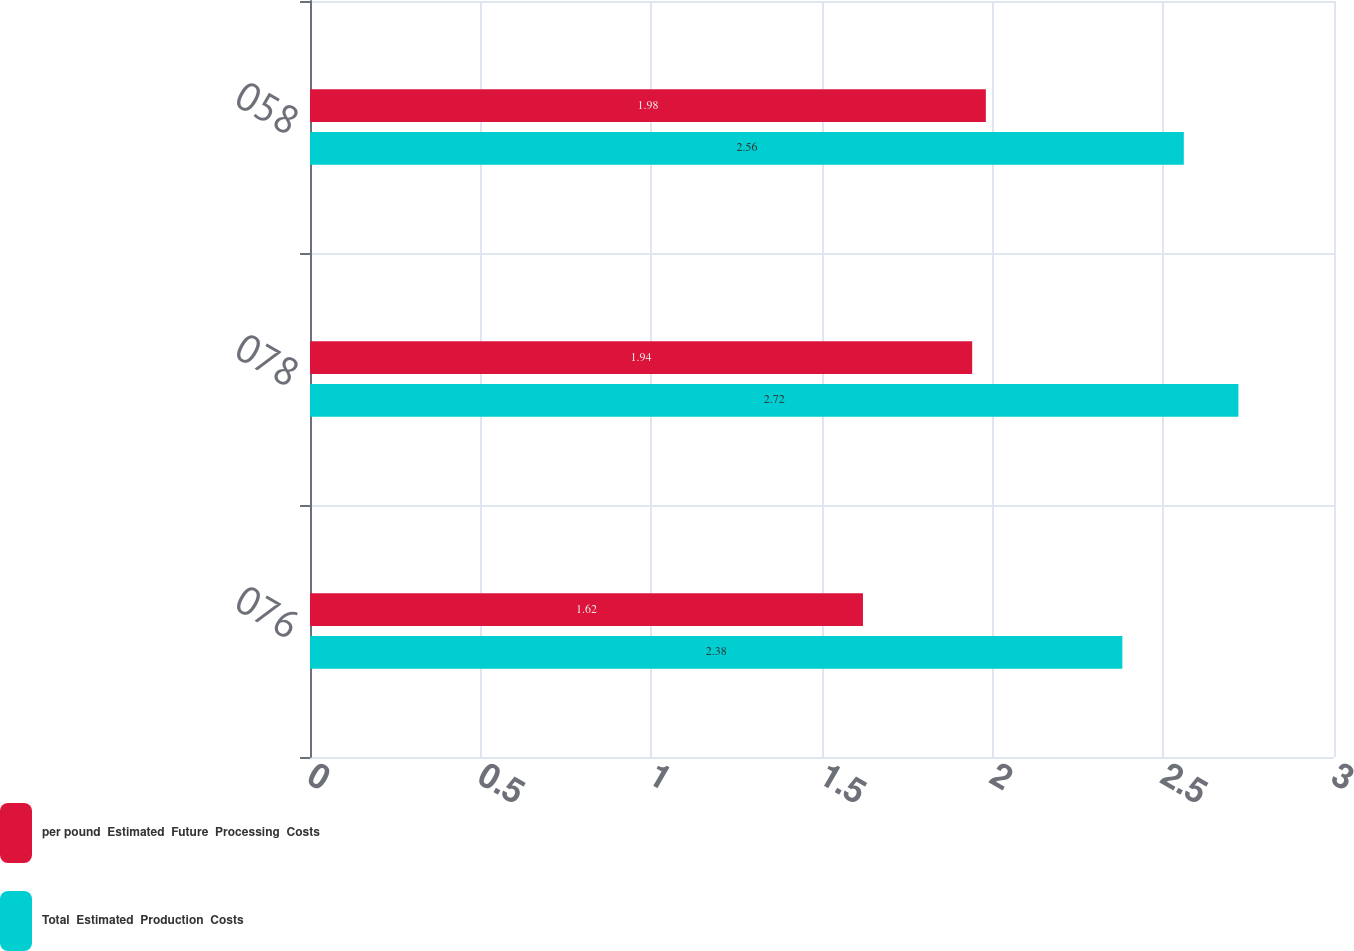<chart> <loc_0><loc_0><loc_500><loc_500><stacked_bar_chart><ecel><fcel>076<fcel>078<fcel>058<nl><fcel>per pound  Estimated  Future  Processing  Costs<fcel>1.62<fcel>1.94<fcel>1.98<nl><fcel>Total  Estimated  Production  Costs<fcel>2.38<fcel>2.72<fcel>2.56<nl></chart> 